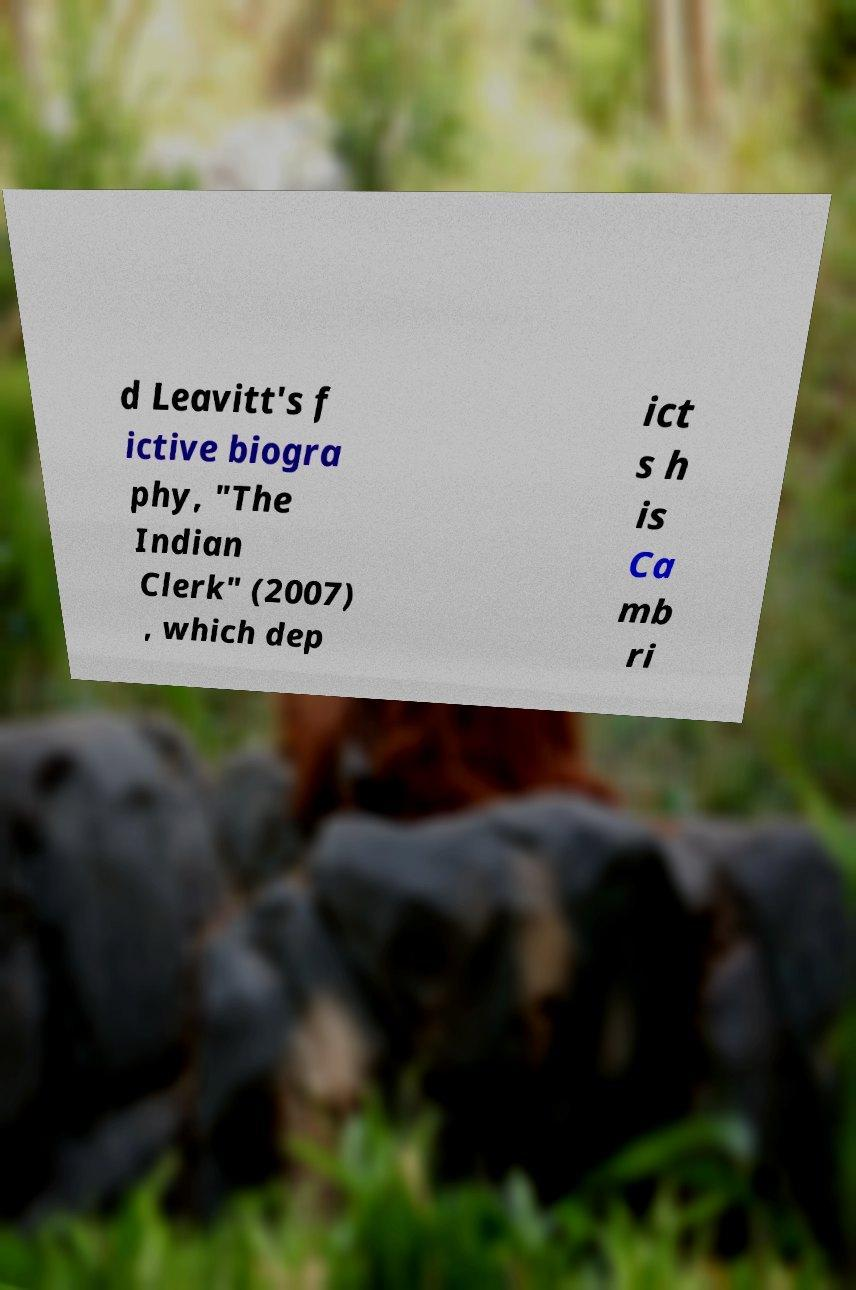Can you accurately transcribe the text from the provided image for me? d Leavitt's f ictive biogra phy, "The Indian Clerk" (2007) , which dep ict s h is Ca mb ri 